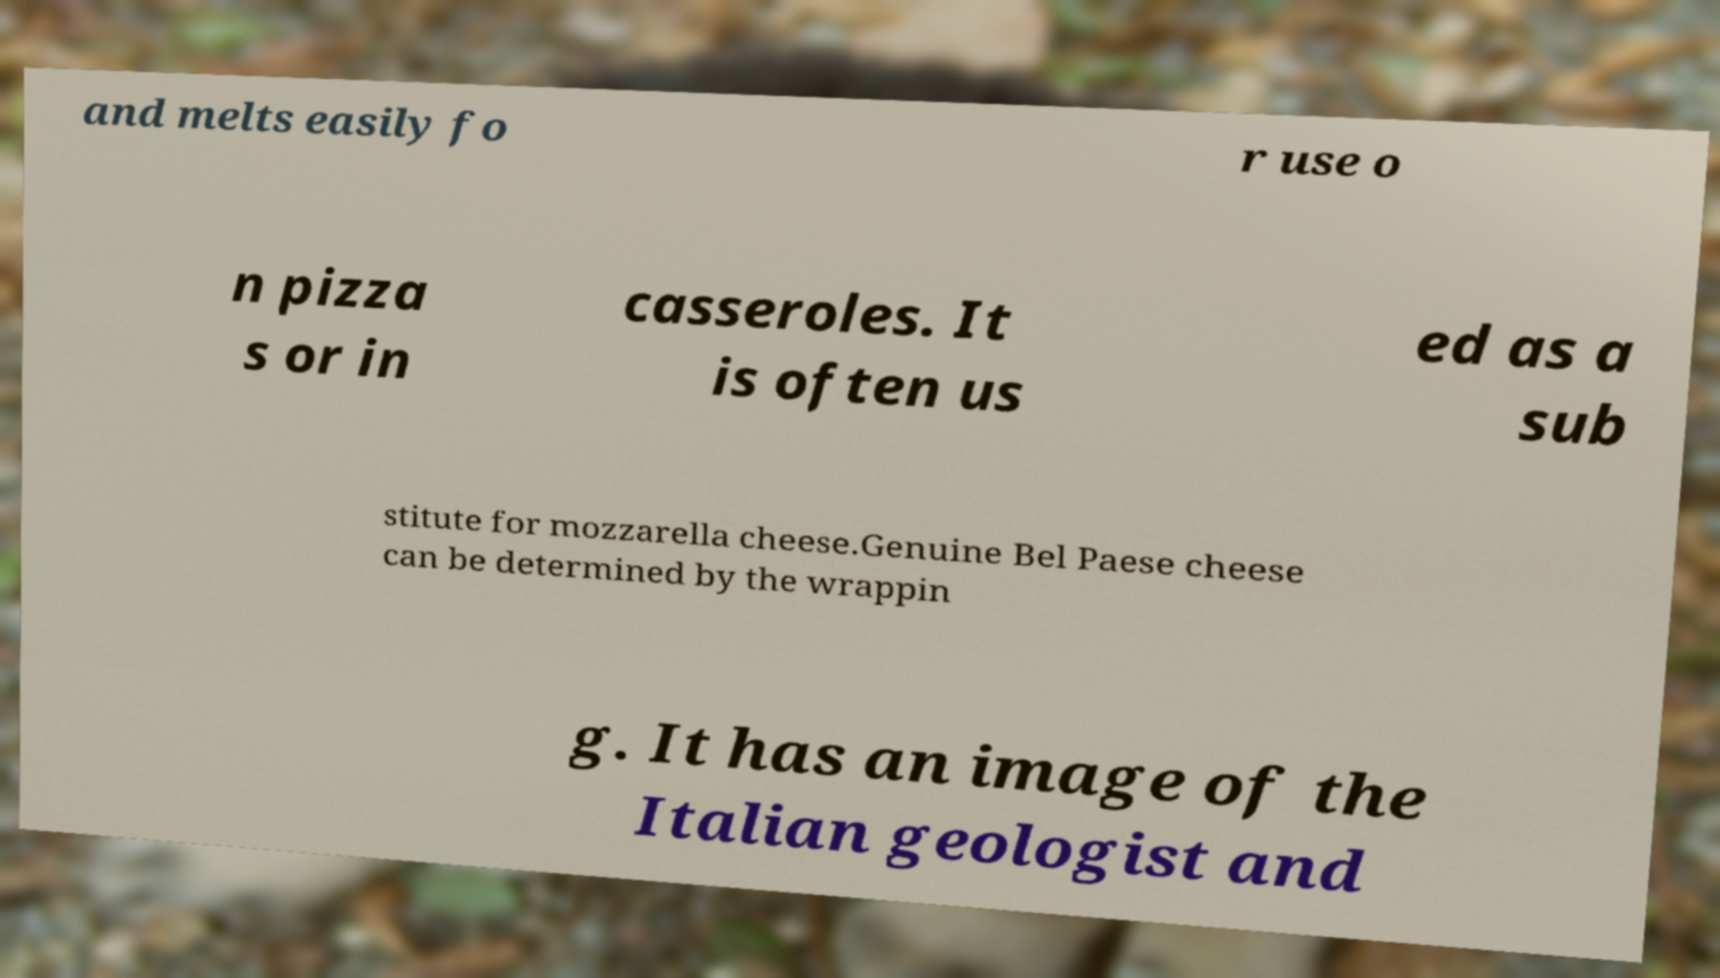I need the written content from this picture converted into text. Can you do that? and melts easily fo r use o n pizza s or in casseroles. It is often us ed as a sub stitute for mozzarella cheese.Genuine Bel Paese cheese can be determined by the wrappin g. It has an image of the Italian geologist and 